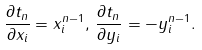<formula> <loc_0><loc_0><loc_500><loc_500>\frac { \partial t _ { n } } { \partial x _ { i } } = x _ { i } ^ { n - 1 } , \, \frac { \partial t _ { n } } { \partial y _ { i } } = - y _ { i } ^ { n - 1 } .</formula> 